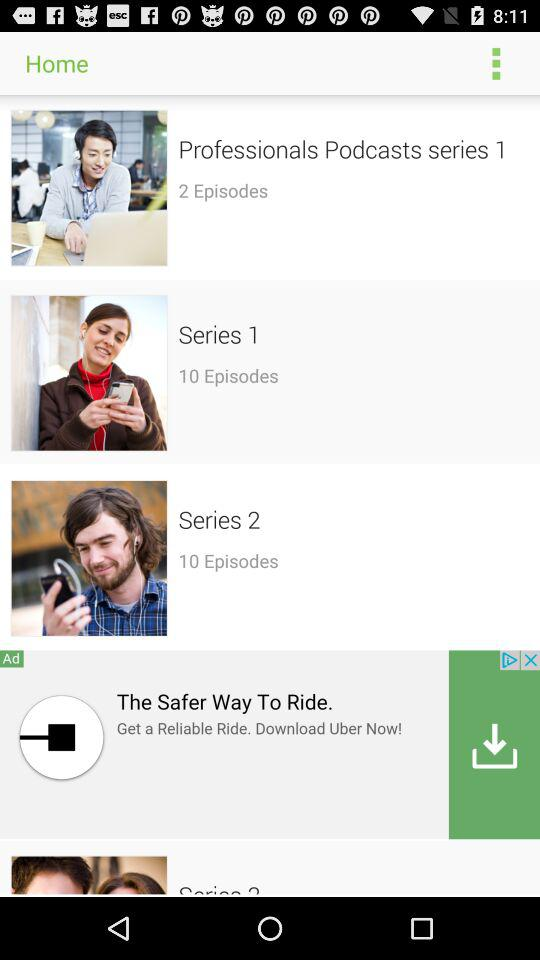How many episodes are in the series with the most episodes?
Answer the question using a single word or phrase. 10 